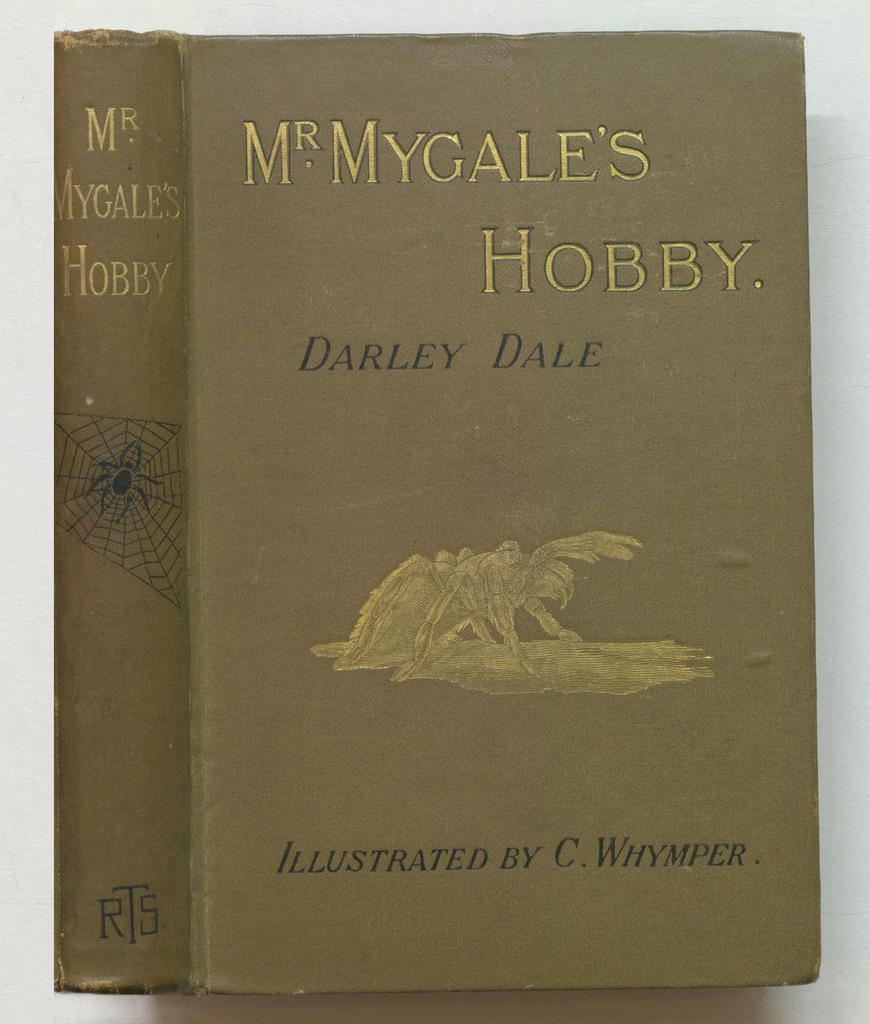<image>
Present a compact description of the photo's key features. Brown book named MyGales Hobby by Darley Dale 